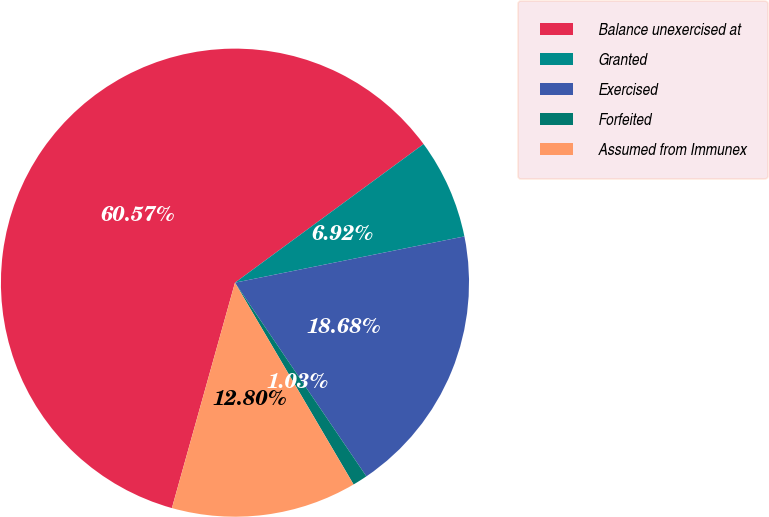<chart> <loc_0><loc_0><loc_500><loc_500><pie_chart><fcel>Balance unexercised at<fcel>Granted<fcel>Exercised<fcel>Forfeited<fcel>Assumed from Immunex<nl><fcel>60.57%<fcel>6.92%<fcel>18.68%<fcel>1.03%<fcel>12.8%<nl></chart> 